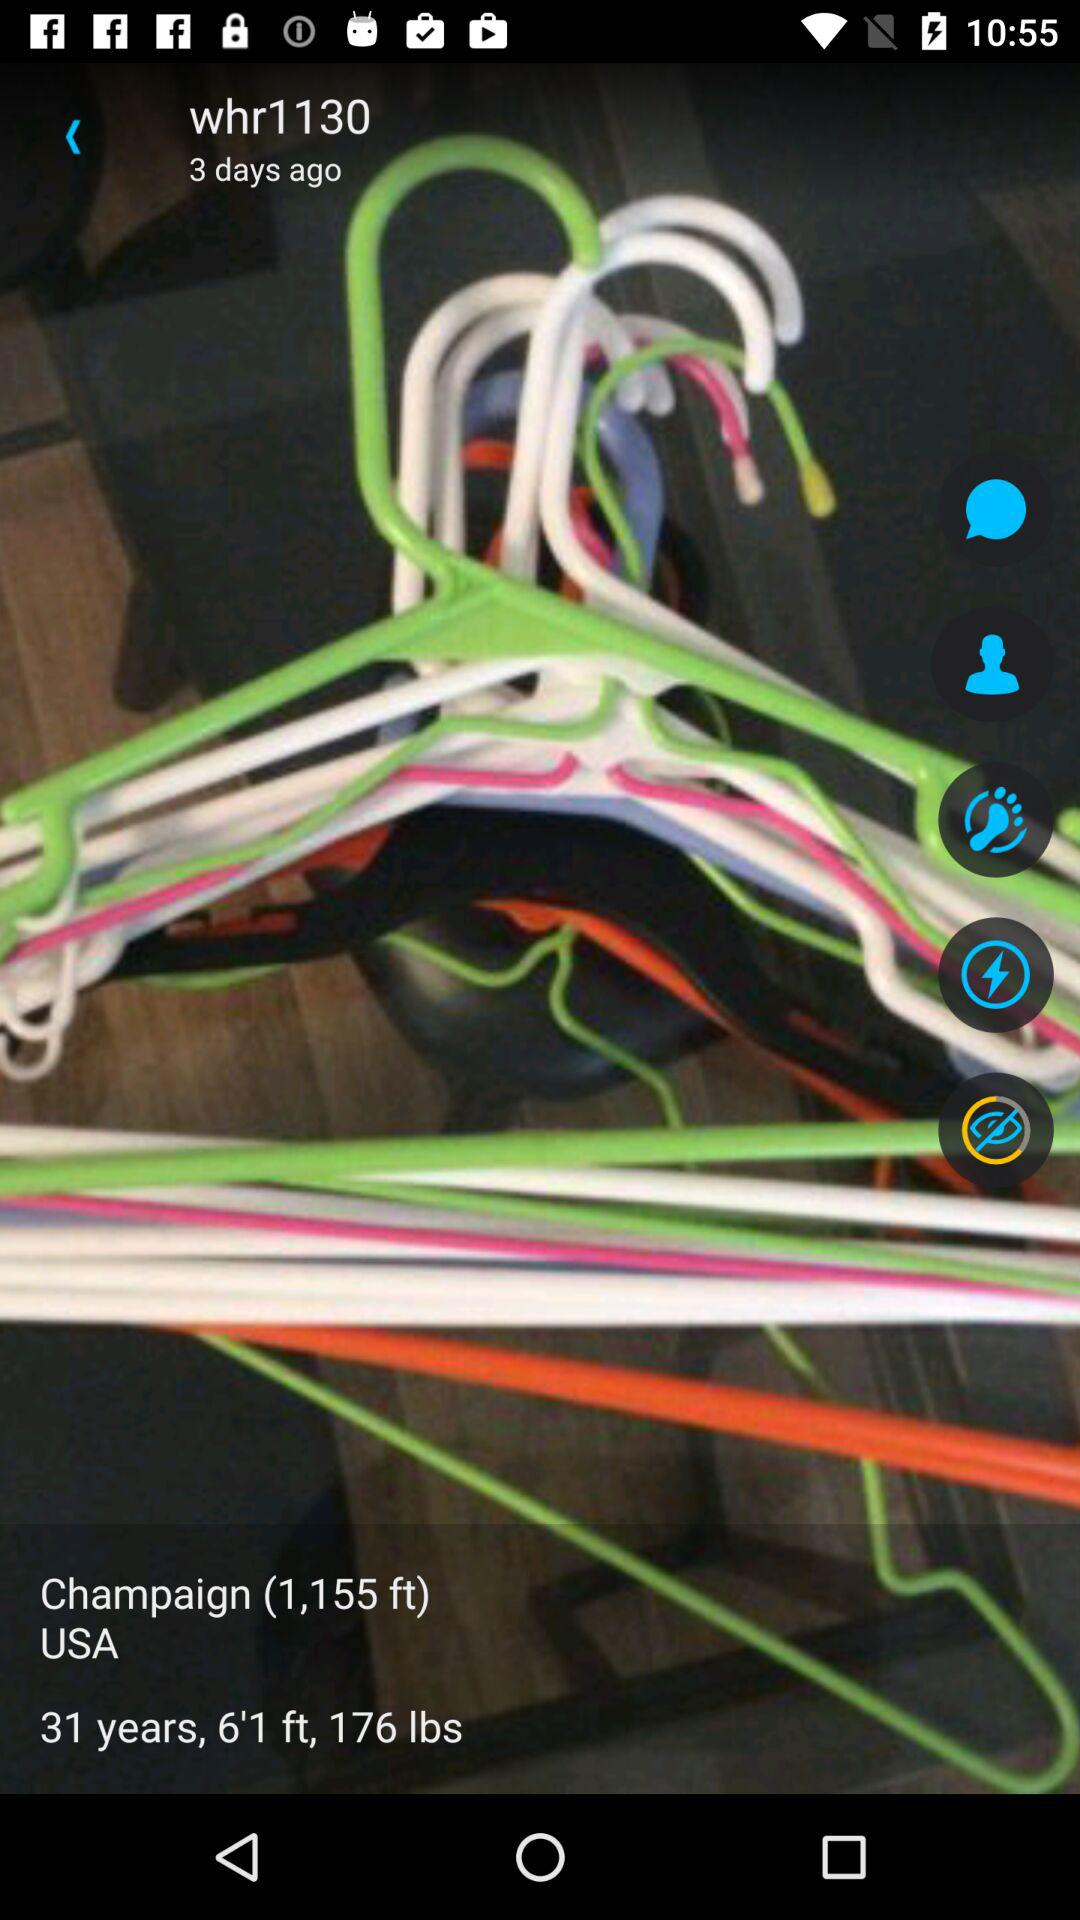What is the weight of the person? The weight of the person is 176 lbs. 